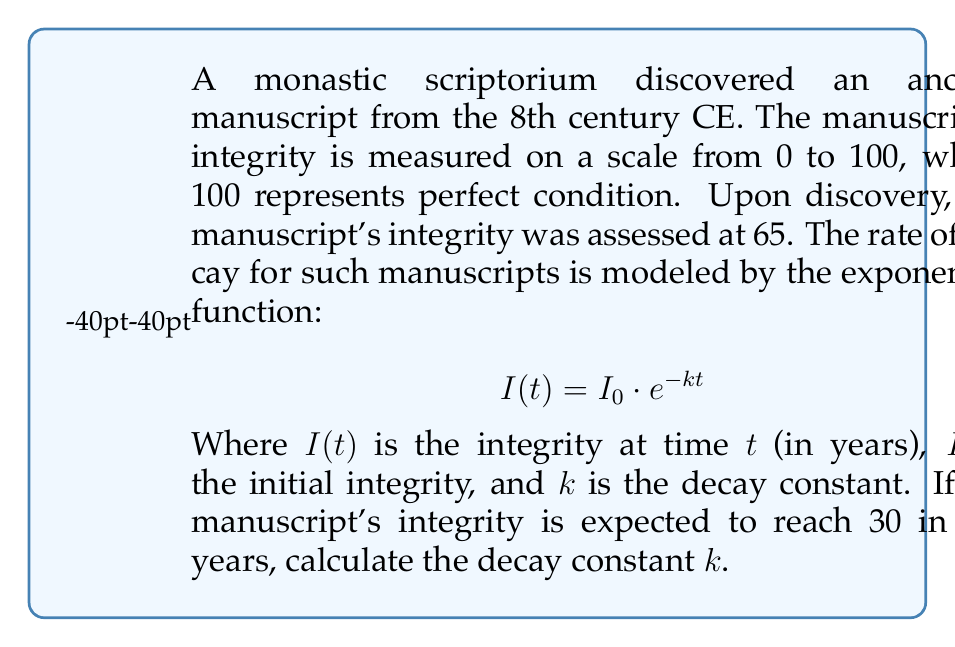Help me with this question. Let's approach this step-by-step:

1) We are given the exponential decay function:
   $$I(t) = I_0 \cdot e^{-kt}$$

2) We know the following:
   - Initial integrity, $I_0 = 65$
   - After 200 years, the integrity will be 30, so $I(200) = 30$
   - We need to find $k$

3) Let's plug these values into our equation:
   $$30 = 65 \cdot e^{-k \cdot 200}$$

4) Now, let's solve for $k$:
   
   Divide both sides by 65:
   $$\frac{30}{65} = e^{-k \cdot 200}$$

   Take the natural logarithm of both sides:
   $$\ln(\frac{30}{65}) = -k \cdot 200$$

   Divide both sides by -200:
   $$\frac{\ln(\frac{30}{65})}{-200} = k$$

5) Now let's calculate:
   $$k = \frac{\ln(\frac{30}{65})}{-200} = \frac{\ln(0.4615...)}{-200} = \frac{-0.7731...}{-200} = 0.003866...$$

Thus, the decay constant $k$ is approximately 0.003866 per year.
Answer: $k \approx 0.003866$ per year 